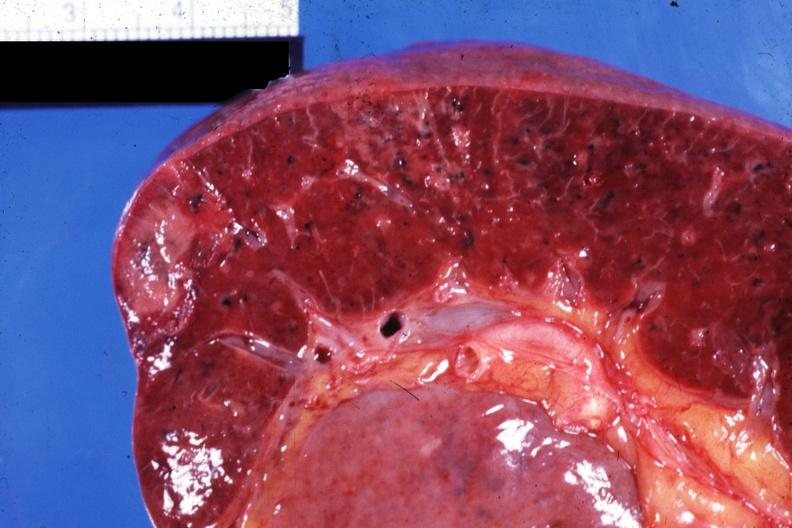s spleen present?
Answer the question using a single word or phrase. Yes 